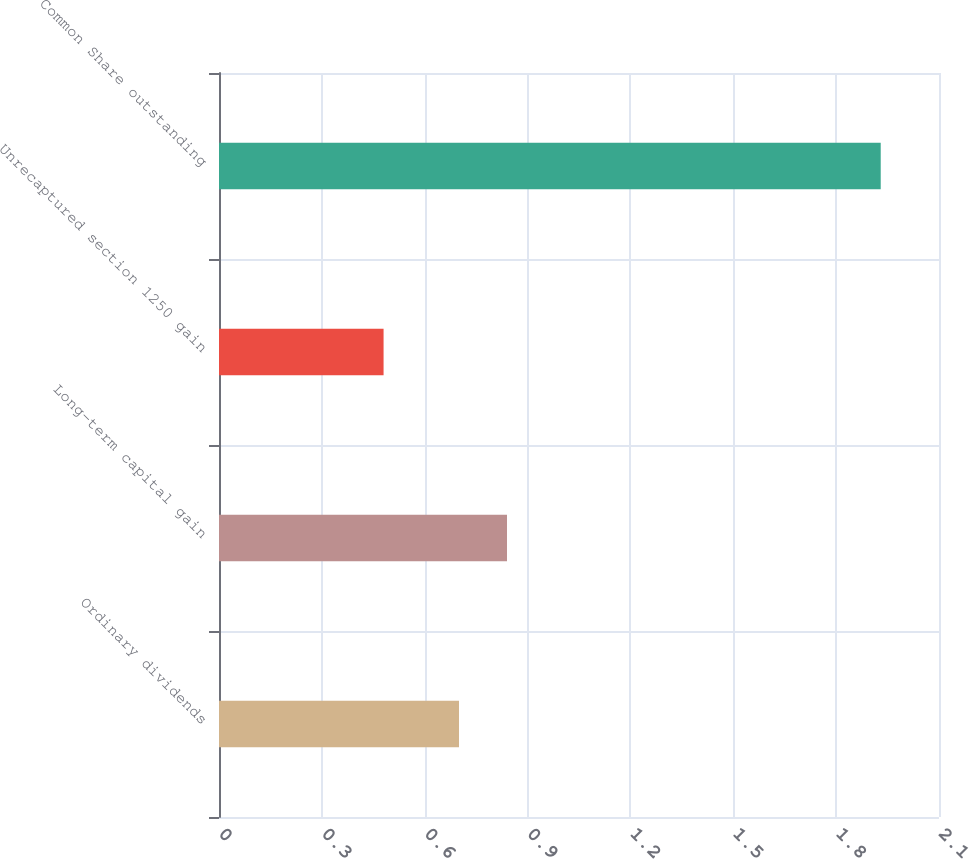Convert chart to OTSL. <chart><loc_0><loc_0><loc_500><loc_500><bar_chart><fcel>Ordinary dividends<fcel>Long-term capital gain<fcel>Unrecaptured section 1250 gain<fcel>Common Share outstanding<nl><fcel>0.7<fcel>0.84<fcel>0.48<fcel>1.93<nl></chart> 